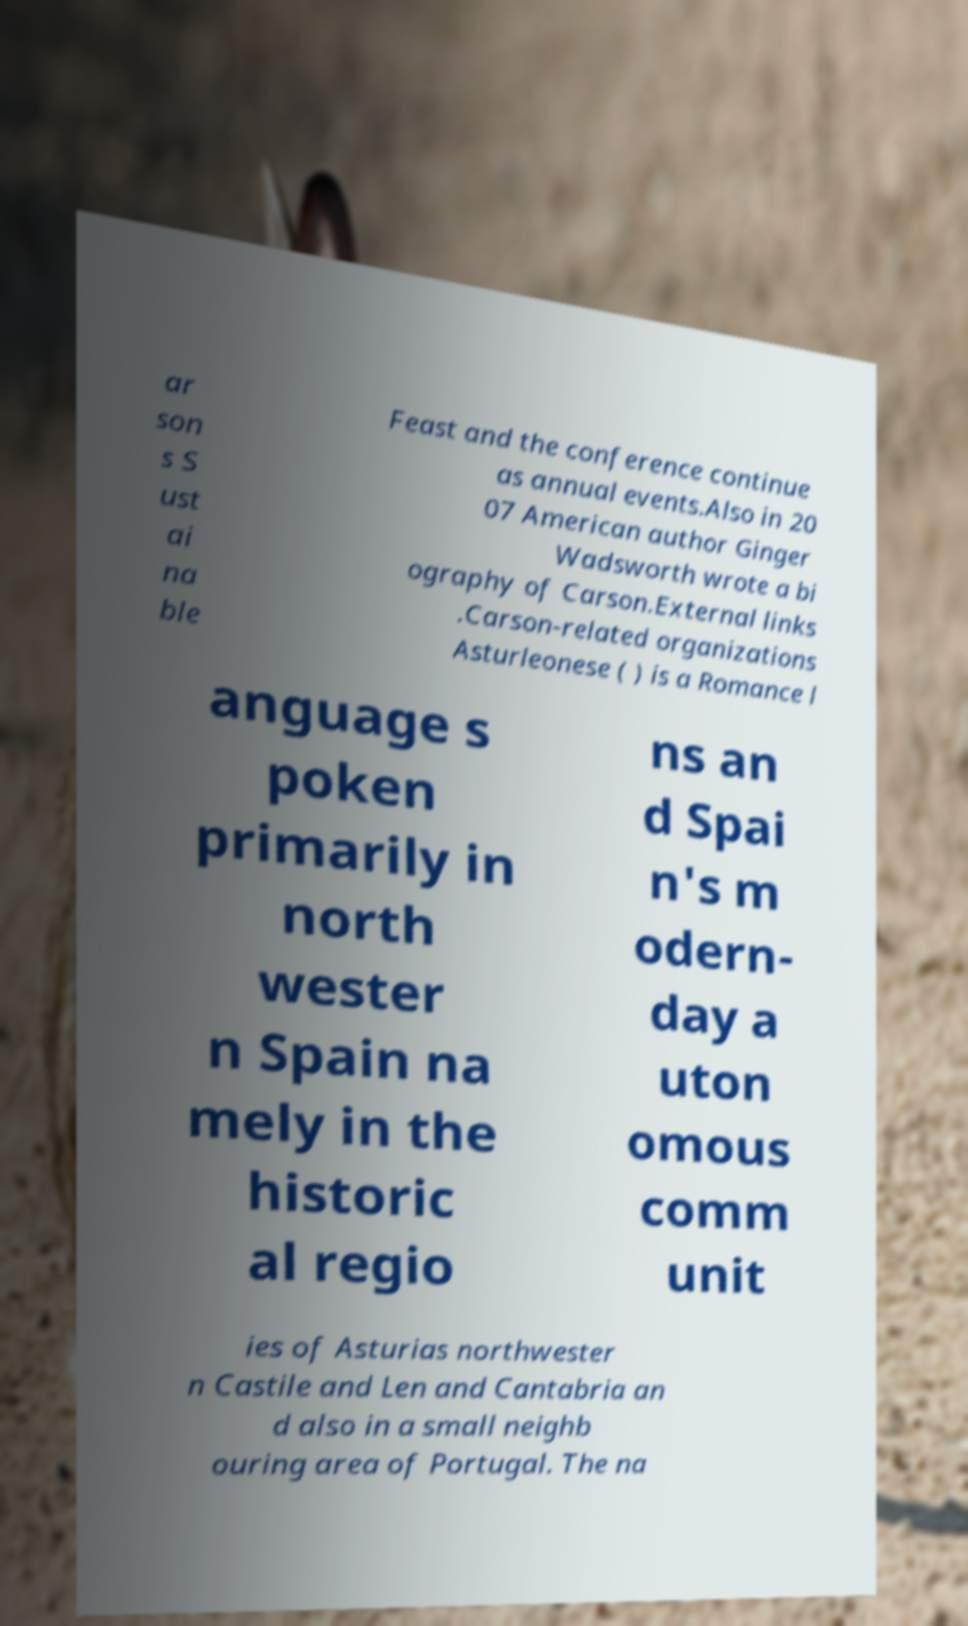There's text embedded in this image that I need extracted. Can you transcribe it verbatim? ar son s S ust ai na ble Feast and the conference continue as annual events.Also in 20 07 American author Ginger Wadsworth wrote a bi ography of Carson.External links .Carson-related organizations Asturleonese ( ) is a Romance l anguage s poken primarily in north wester n Spain na mely in the historic al regio ns an d Spai n's m odern- day a uton omous comm unit ies of Asturias northwester n Castile and Len and Cantabria an d also in a small neighb ouring area of Portugal. The na 